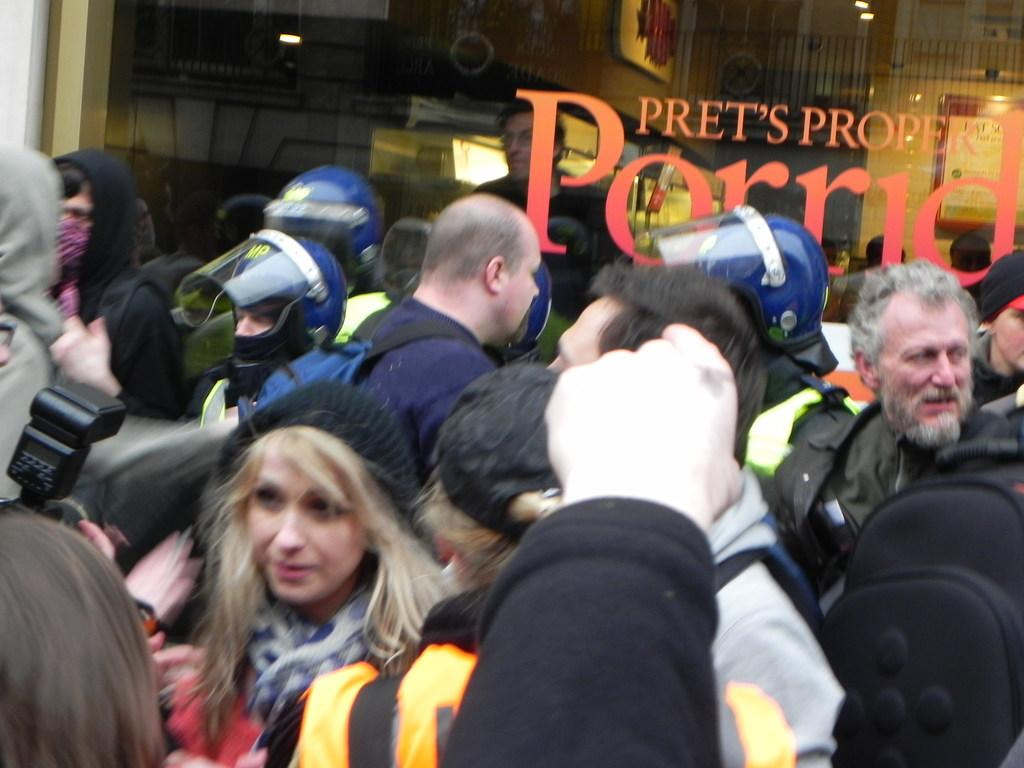What is the main subject of the image? There is a beautiful woman in the image. Can you describe the woman's attire? The woman is wearing a black cap. Are there any other people in the image? Yes, there are other persons in the image. What type of architectural feature can be seen in the image? There is a glass wall in the image. What type of yard can be seen in the image? There is no yard present in the image. What mark is visible on the woman's forehead in the image? There is no mark visible on the woman's forehead in the image. 